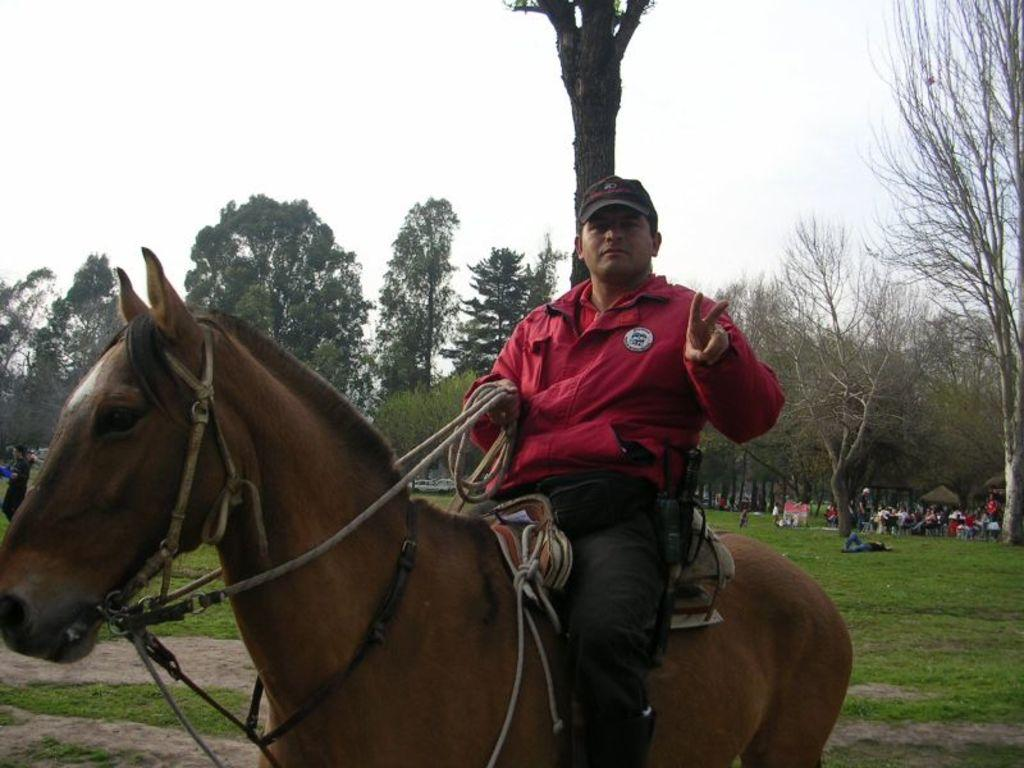What animal is present in the image? There is a horse in the image. Is there anyone riding the horse? Yes, there is a person on the horse. What type of environment is depicted in the image? There are trees and grass visible in the image, suggesting a natural setting. Are there any other people in the image besides the person on the horse? Yes, there are other people in the image. What type of ship can be seen sailing in the image? There is no ship present in the image. 